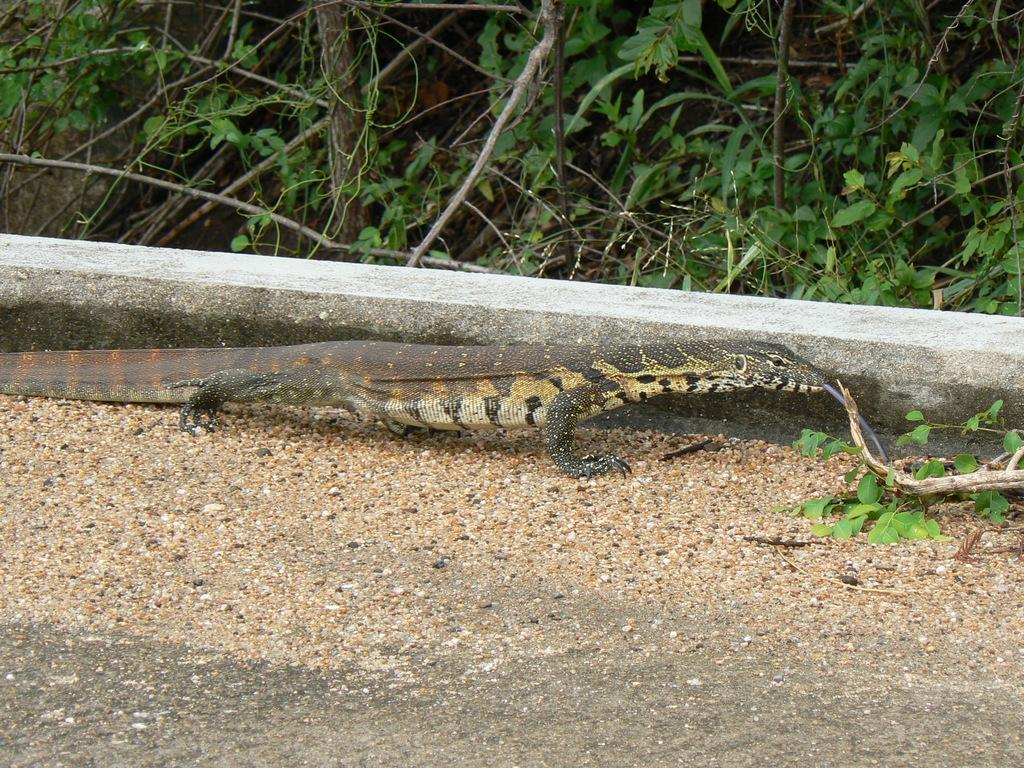What type of animal is on the ground in the image? The specific type of animal cannot be determined from the provided facts. What can be seen in the background of the image? There are plants and trees in the background of the image. What type of soap is being used to destroy the trees in the image? There is no soap or destruction present in the image. The image features an animal on the ground and plants and trees in the background. 